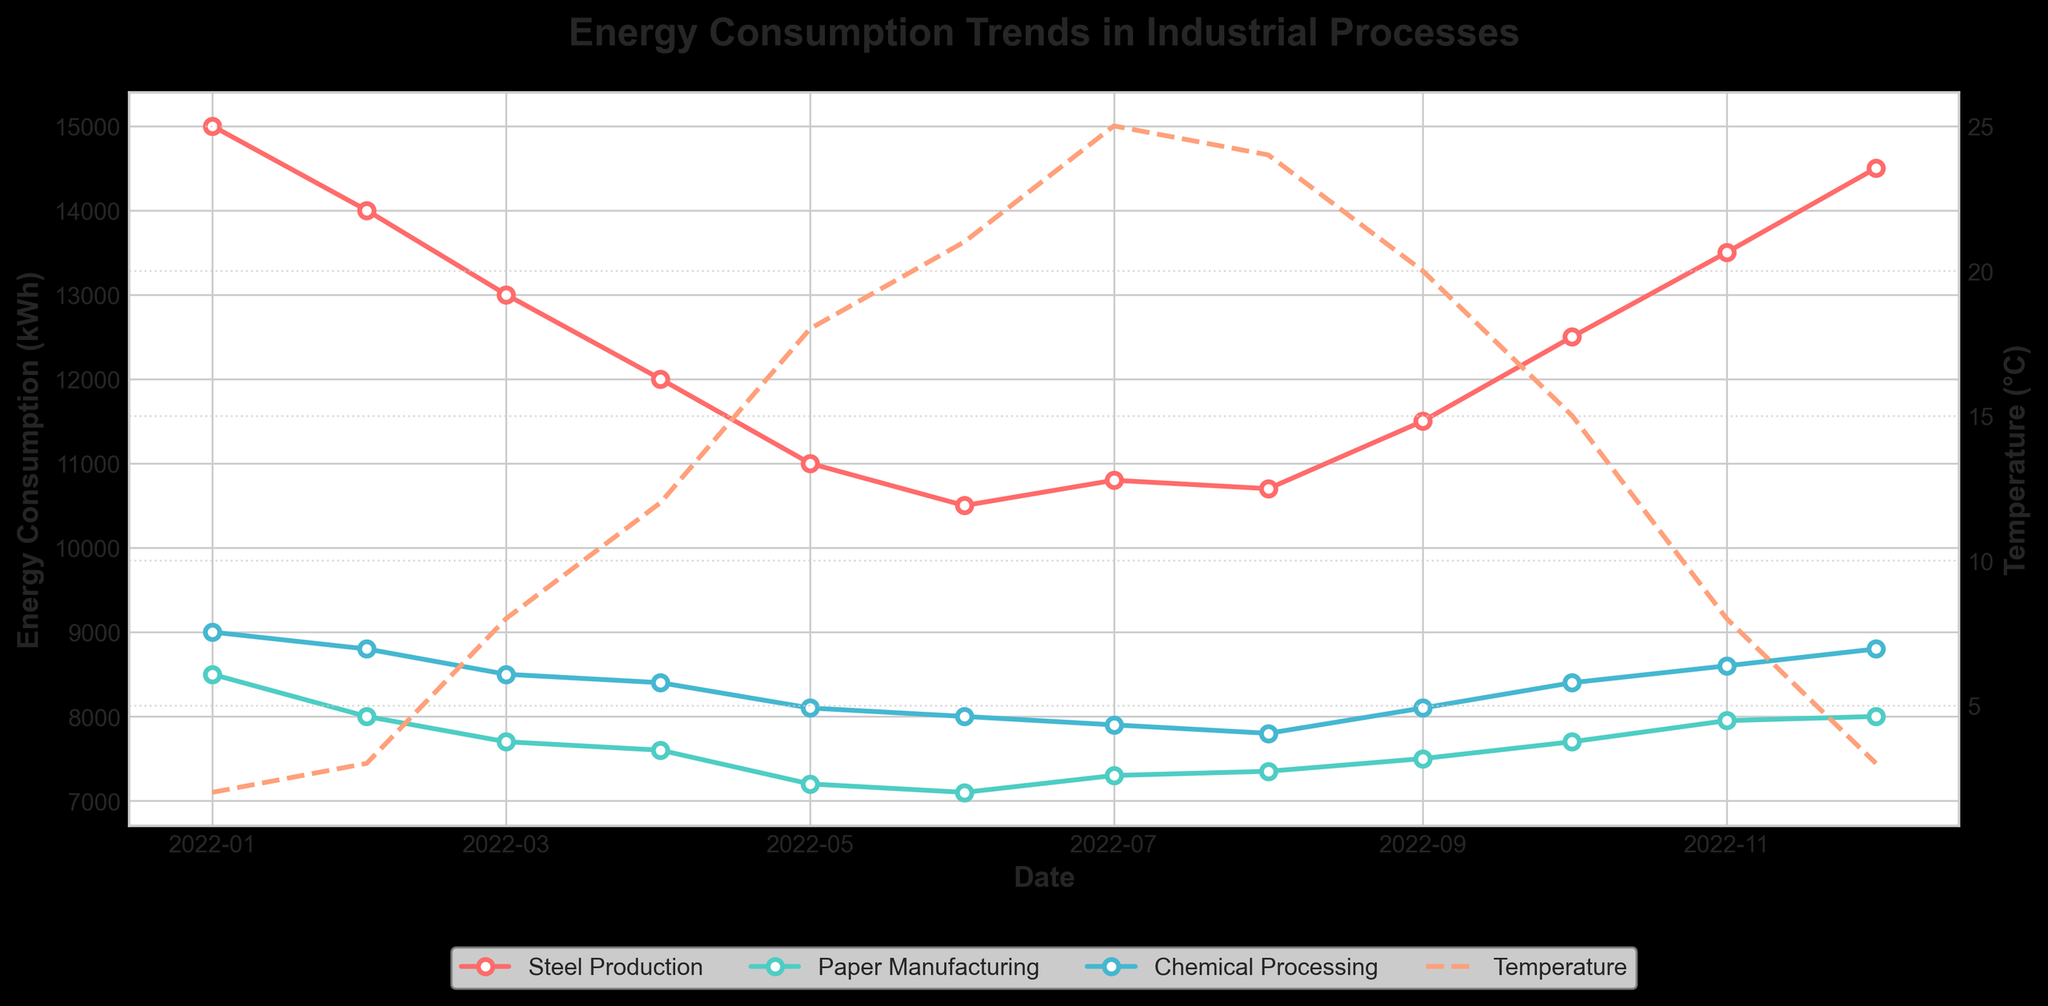How many unique processes are analyzed in the figure? Based on the data and the plot, count the unique process lines. The data shows three processes: Steel Production, Paper Manufacturing, and Chemical Processing.
Answer: 3 What is the general trend of energy consumption in Steel Production from January to December 2022? By observing the Steel Production line, which starts at 15,000 kWh in January and ends at 14,500 kWh in December, with a dip in the middle months.
Answer: Decreasing Which month shows the highest energy consumption for Paper Manufacturing? Look at the Paper Manufacturing line and identify the month where the energy consumption peak occurs. It starts at 8,500 kWh and peaks again in December at 8,000 kWh.
Answer: January How does the energy consumption trend of Chemical Processing compare to that of Steel Production in summer months? Compare the lines for Chemical Processing and Steel Production during June, July, and August. Chemical Processing has a stable consumption around 7,800 to 8,000 kWh, while Steel Production varies between 10,500 and 10,800 kWh.
Answer: More stable Across all processes, during which month is the lowest average temperature observed? Check the temperature line for the lowest point, which clearly occurs at the beginning and end of the year: January and December at 2°C.
Answer: January and December What is the difference in Steel Production energy consumption between the highest (January) and lowest (June) months? Calculate the difference between the two values: 15,000 kWh in January and 10,500 kWh in June. So, 15,000 - 10,500.
Answer: 4,500 kWh What is the relationship between temperature and energy consumption for Chemical Processing? Observe the temperature line in relation to the Chemical Processing line. There’s a slight decrease in energy consumption as the temperature increases, except for a slight uptick in November and December.
Answer: Slightly inversely related Which process has the most fluctuation in energy consumption over the year? Look at the lines to see which one varies the most. Steel Production shows the largest fluctuations compared to Paper Manufacturing and Chemical Processing.
Answer: Steel Production How does the energy consumption in November for Paper Manufacturing compare to that in August? Compare values for each month. November shows 7,950 kWh while August is 7,350 kWh. So, 7,950 - 7,350.
Answer: 600 kWh higher 